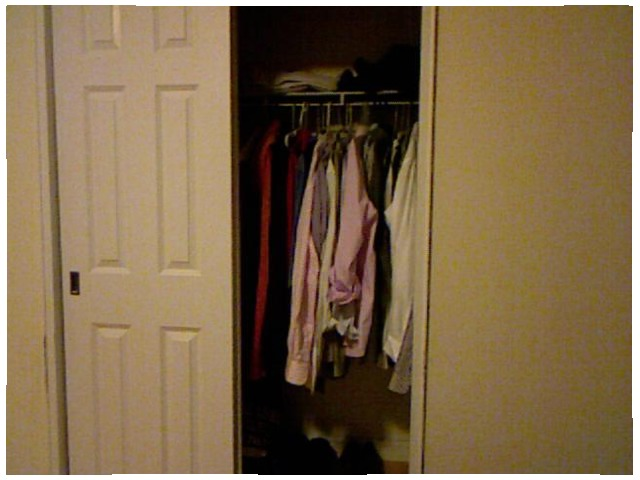<image>
Can you confirm if the clothing is in front of the door? No. The clothing is not in front of the door. The spatial positioning shows a different relationship between these objects. Is there a shirt behind the door? Yes. From this viewpoint, the shirt is positioned behind the door, with the door partially or fully occluding the shirt. 